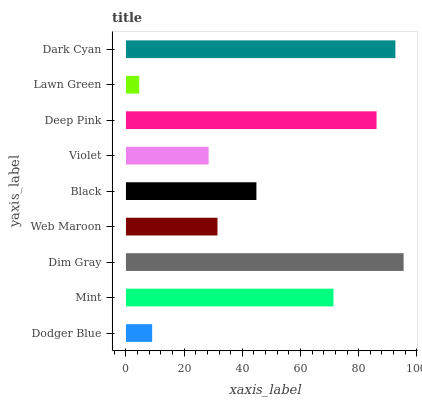Is Lawn Green the minimum?
Answer yes or no. Yes. Is Dim Gray the maximum?
Answer yes or no. Yes. Is Mint the minimum?
Answer yes or no. No. Is Mint the maximum?
Answer yes or no. No. Is Mint greater than Dodger Blue?
Answer yes or no. Yes. Is Dodger Blue less than Mint?
Answer yes or no. Yes. Is Dodger Blue greater than Mint?
Answer yes or no. No. Is Mint less than Dodger Blue?
Answer yes or no. No. Is Black the high median?
Answer yes or no. Yes. Is Black the low median?
Answer yes or no. Yes. Is Violet the high median?
Answer yes or no. No. Is Violet the low median?
Answer yes or no. No. 